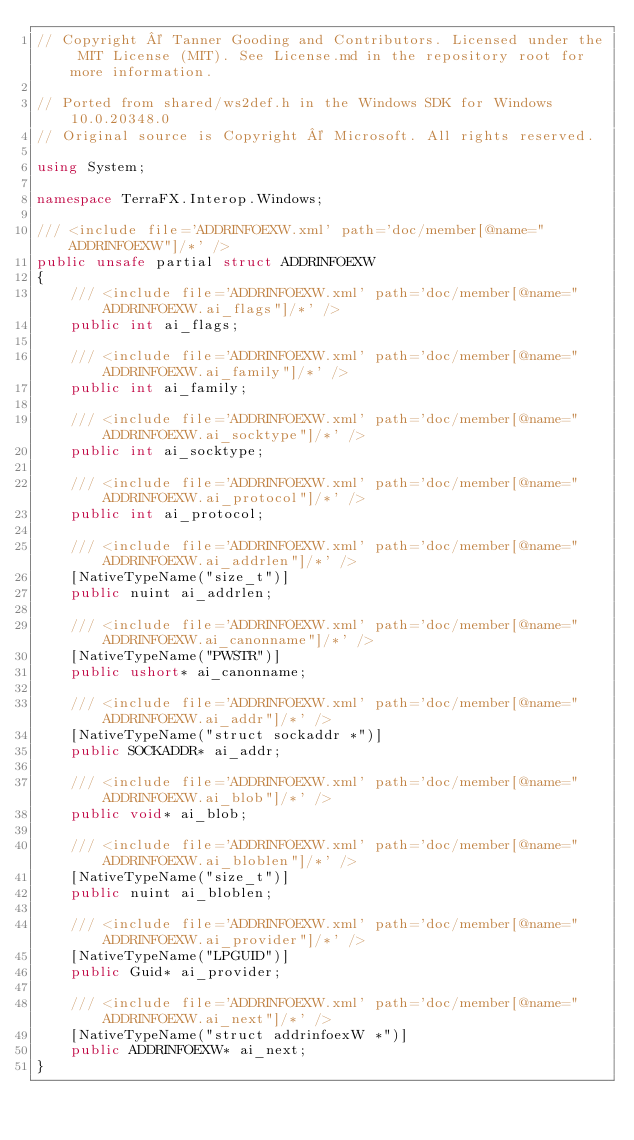Convert code to text. <code><loc_0><loc_0><loc_500><loc_500><_C#_>// Copyright © Tanner Gooding and Contributors. Licensed under the MIT License (MIT). See License.md in the repository root for more information.

// Ported from shared/ws2def.h in the Windows SDK for Windows 10.0.20348.0
// Original source is Copyright © Microsoft. All rights reserved.

using System;

namespace TerraFX.Interop.Windows;

/// <include file='ADDRINFOEXW.xml' path='doc/member[@name="ADDRINFOEXW"]/*' />
public unsafe partial struct ADDRINFOEXW
{
    /// <include file='ADDRINFOEXW.xml' path='doc/member[@name="ADDRINFOEXW.ai_flags"]/*' />
    public int ai_flags;

    /// <include file='ADDRINFOEXW.xml' path='doc/member[@name="ADDRINFOEXW.ai_family"]/*' />
    public int ai_family;

    /// <include file='ADDRINFOEXW.xml' path='doc/member[@name="ADDRINFOEXW.ai_socktype"]/*' />
    public int ai_socktype;

    /// <include file='ADDRINFOEXW.xml' path='doc/member[@name="ADDRINFOEXW.ai_protocol"]/*' />
    public int ai_protocol;

    /// <include file='ADDRINFOEXW.xml' path='doc/member[@name="ADDRINFOEXW.ai_addrlen"]/*' />
    [NativeTypeName("size_t")]
    public nuint ai_addrlen;

    /// <include file='ADDRINFOEXW.xml' path='doc/member[@name="ADDRINFOEXW.ai_canonname"]/*' />
    [NativeTypeName("PWSTR")]
    public ushort* ai_canonname;

    /// <include file='ADDRINFOEXW.xml' path='doc/member[@name="ADDRINFOEXW.ai_addr"]/*' />
    [NativeTypeName("struct sockaddr *")]
    public SOCKADDR* ai_addr;

    /// <include file='ADDRINFOEXW.xml' path='doc/member[@name="ADDRINFOEXW.ai_blob"]/*' />
    public void* ai_blob;

    /// <include file='ADDRINFOEXW.xml' path='doc/member[@name="ADDRINFOEXW.ai_bloblen"]/*' />
    [NativeTypeName("size_t")]
    public nuint ai_bloblen;

    /// <include file='ADDRINFOEXW.xml' path='doc/member[@name="ADDRINFOEXW.ai_provider"]/*' />
    [NativeTypeName("LPGUID")]
    public Guid* ai_provider;

    /// <include file='ADDRINFOEXW.xml' path='doc/member[@name="ADDRINFOEXW.ai_next"]/*' />
    [NativeTypeName("struct addrinfoexW *")]
    public ADDRINFOEXW* ai_next;
}
</code> 